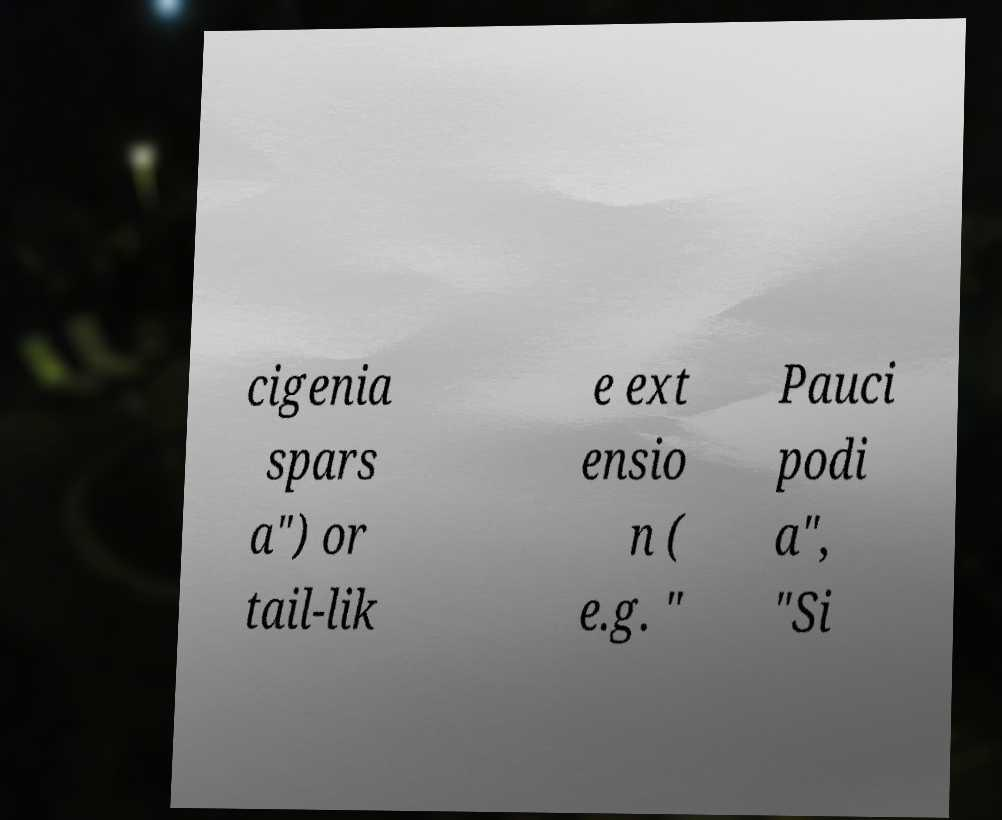I need the written content from this picture converted into text. Can you do that? cigenia spars a") or tail-lik e ext ensio n ( e.g. " Pauci podi a", "Si 